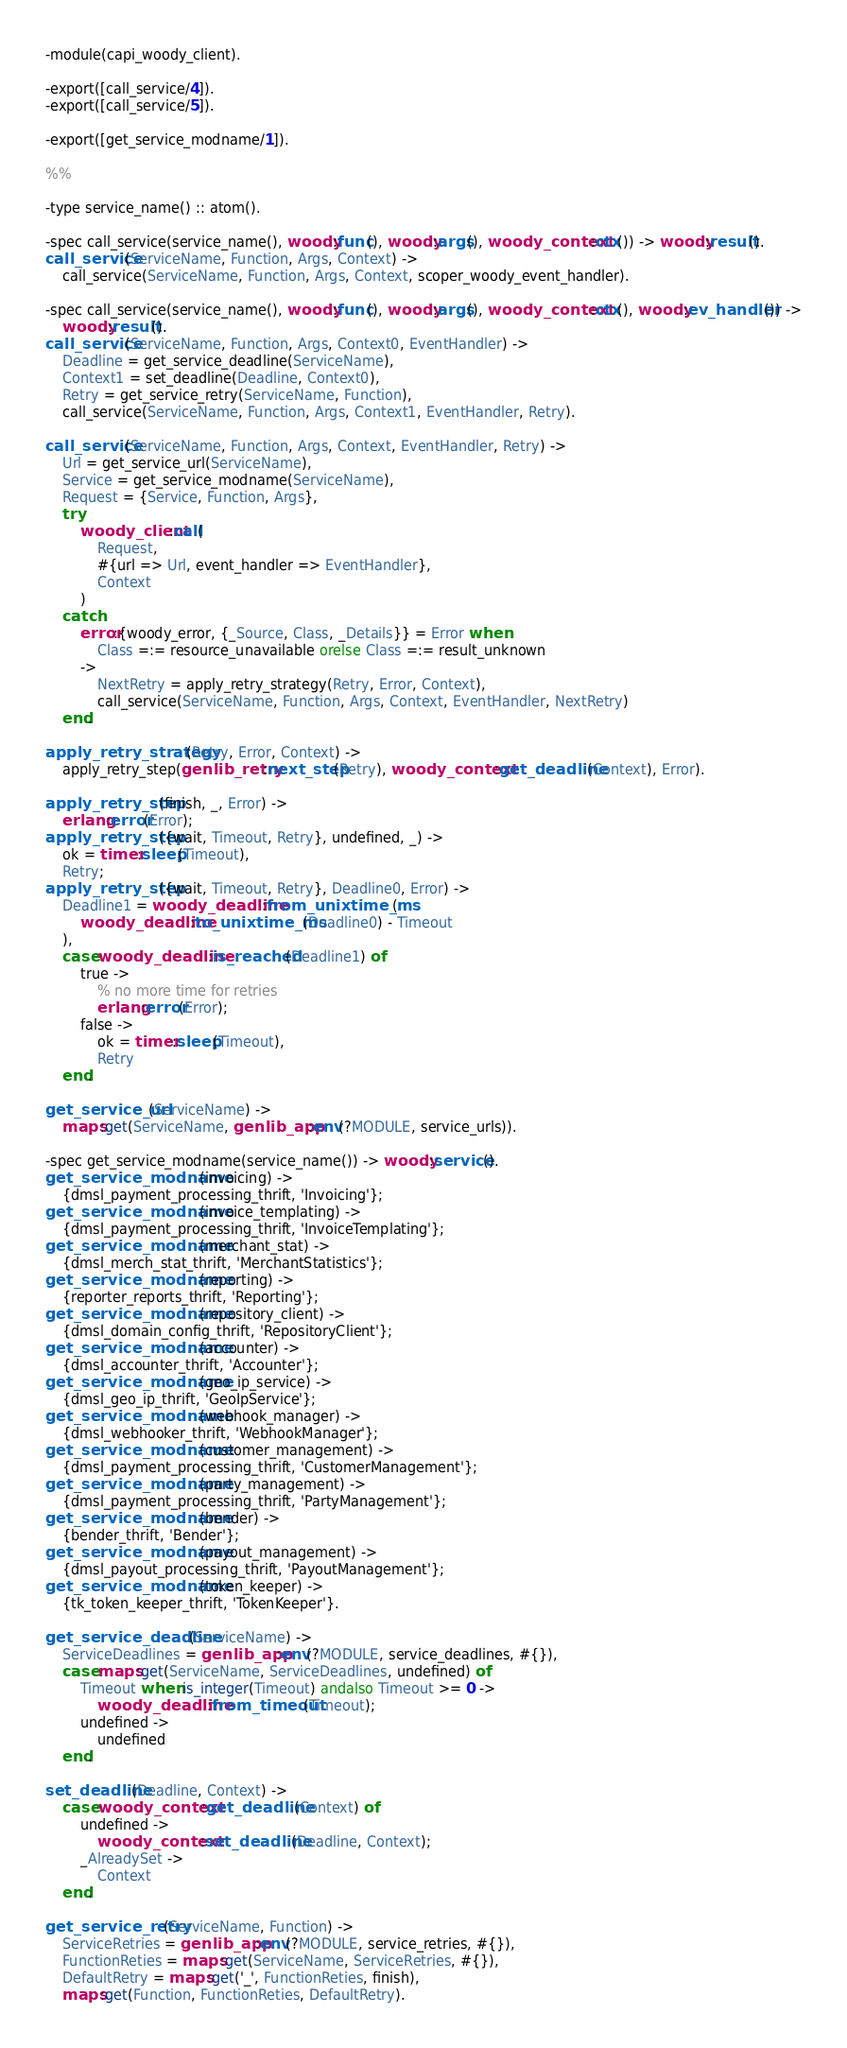Convert code to text. <code><loc_0><loc_0><loc_500><loc_500><_Erlang_>-module(capi_woody_client).

-export([call_service/4]).
-export([call_service/5]).

-export([get_service_modname/1]).

%%

-type service_name() :: atom().

-spec call_service(service_name(), woody:func(), woody:args(), woody_context:ctx()) -> woody:result().
call_service(ServiceName, Function, Args, Context) ->
    call_service(ServiceName, Function, Args, Context, scoper_woody_event_handler).

-spec call_service(service_name(), woody:func(), woody:args(), woody_context:ctx(), woody:ev_handler()) ->
    woody:result().
call_service(ServiceName, Function, Args, Context0, EventHandler) ->
    Deadline = get_service_deadline(ServiceName),
    Context1 = set_deadline(Deadline, Context0),
    Retry = get_service_retry(ServiceName, Function),
    call_service(ServiceName, Function, Args, Context1, EventHandler, Retry).

call_service(ServiceName, Function, Args, Context, EventHandler, Retry) ->
    Url = get_service_url(ServiceName),
    Service = get_service_modname(ServiceName),
    Request = {Service, Function, Args},
    try
        woody_client:call(
            Request,
            #{url => Url, event_handler => EventHandler},
            Context
        )
    catch
        error:{woody_error, {_Source, Class, _Details}} = Error when
            Class =:= resource_unavailable orelse Class =:= result_unknown
        ->
            NextRetry = apply_retry_strategy(Retry, Error, Context),
            call_service(ServiceName, Function, Args, Context, EventHandler, NextRetry)
    end.

apply_retry_strategy(Retry, Error, Context) ->
    apply_retry_step(genlib_retry:next_step(Retry), woody_context:get_deadline(Context), Error).

apply_retry_step(finish, _, Error) ->
    erlang:error(Error);
apply_retry_step({wait, Timeout, Retry}, undefined, _) ->
    ok = timer:sleep(Timeout),
    Retry;
apply_retry_step({wait, Timeout, Retry}, Deadline0, Error) ->
    Deadline1 = woody_deadline:from_unixtime_ms(
        woody_deadline:to_unixtime_ms(Deadline0) - Timeout
    ),
    case woody_deadline:is_reached(Deadline1) of
        true ->
            % no more time for retries
            erlang:error(Error);
        false ->
            ok = timer:sleep(Timeout),
            Retry
    end.

get_service_url(ServiceName) ->
    maps:get(ServiceName, genlib_app:env(?MODULE, service_urls)).

-spec get_service_modname(service_name()) -> woody:service().
get_service_modname(invoicing) ->
    {dmsl_payment_processing_thrift, 'Invoicing'};
get_service_modname(invoice_templating) ->
    {dmsl_payment_processing_thrift, 'InvoiceTemplating'};
get_service_modname(merchant_stat) ->
    {dmsl_merch_stat_thrift, 'MerchantStatistics'};
get_service_modname(reporting) ->
    {reporter_reports_thrift, 'Reporting'};
get_service_modname(repository_client) ->
    {dmsl_domain_config_thrift, 'RepositoryClient'};
get_service_modname(accounter) ->
    {dmsl_accounter_thrift, 'Accounter'};
get_service_modname(geo_ip_service) ->
    {dmsl_geo_ip_thrift, 'GeoIpService'};
get_service_modname(webhook_manager) ->
    {dmsl_webhooker_thrift, 'WebhookManager'};
get_service_modname(customer_management) ->
    {dmsl_payment_processing_thrift, 'CustomerManagement'};
get_service_modname(party_management) ->
    {dmsl_payment_processing_thrift, 'PartyManagement'};
get_service_modname(bender) ->
    {bender_thrift, 'Bender'};
get_service_modname(payout_management) ->
    {dmsl_payout_processing_thrift, 'PayoutManagement'};
get_service_modname(token_keeper) ->
    {tk_token_keeper_thrift, 'TokenKeeper'}.

get_service_deadline(ServiceName) ->
    ServiceDeadlines = genlib_app:env(?MODULE, service_deadlines, #{}),
    case maps:get(ServiceName, ServiceDeadlines, undefined) of
        Timeout when is_integer(Timeout) andalso Timeout >= 0 ->
            woody_deadline:from_timeout(Timeout);
        undefined ->
            undefined
    end.

set_deadline(Deadline, Context) ->
    case woody_context:get_deadline(Context) of
        undefined ->
            woody_context:set_deadline(Deadline, Context);
        _AlreadySet ->
            Context
    end.

get_service_retry(ServiceName, Function) ->
    ServiceRetries = genlib_app:env(?MODULE, service_retries, #{}),
    FunctionReties = maps:get(ServiceName, ServiceRetries, #{}),
    DefaultRetry = maps:get('_', FunctionReties, finish),
    maps:get(Function, FunctionReties, DefaultRetry).
</code> 